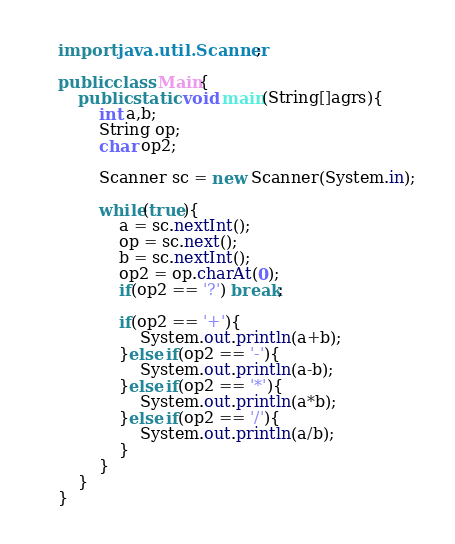<code> <loc_0><loc_0><loc_500><loc_500><_Java_>import java.util.Scanner;

public class Main{
    public static void main(String[]agrs){
        int a,b;
        String op;
        char op2;

        Scanner sc = new Scanner(System.in);

        while(true){
            a = sc.nextInt();
            op = sc.next();
            b = sc.nextInt();
            op2 = op.charAt(0);
            if(op2 == '?') break;
        
            if(op2 == '+'){
                System.out.println(a+b);
            }else if(op2 == '-'){
                System.out.println(a-b);
            }else if(op2 == '*'){
                System.out.println(a*b);
            }else if(op2 == '/'){
                System.out.println(a/b);
            }
        }
    }    
}
</code> 